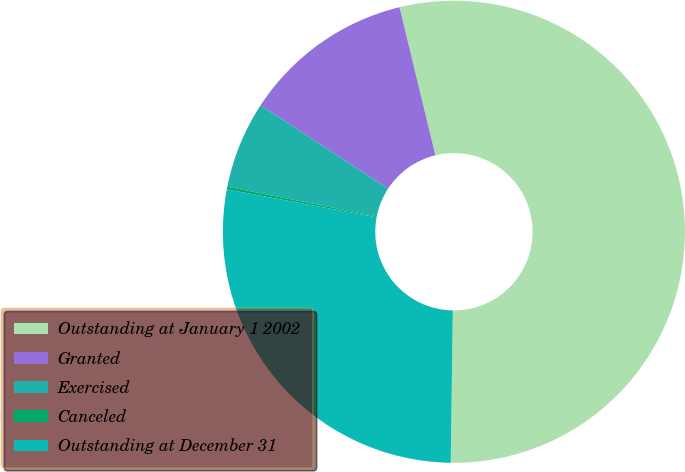Convert chart. <chart><loc_0><loc_0><loc_500><loc_500><pie_chart><fcel>Outstanding at January 1 2002<fcel>Granted<fcel>Exercised<fcel>Canceled<fcel>Outstanding at December 31<nl><fcel>54.0%<fcel>12.0%<fcel>6.09%<fcel>0.19%<fcel>27.72%<nl></chart> 